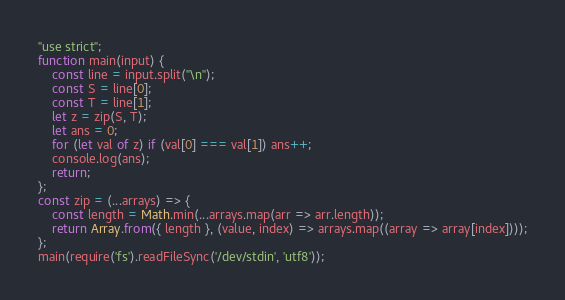Convert code to text. <code><loc_0><loc_0><loc_500><loc_500><_JavaScript_>"use strict";
function main(input) {
    const line = input.split("\n");
    const S = line[0];
    const T = line[1];
    let z = zip(S, T);
    let ans = 0;
    for (let val of z) if (val[0] === val[1]) ans++;
    console.log(ans);
    return;
};
const zip = (...arrays) => {
    const length = Math.min(...arrays.map(arr => arr.length));
    return Array.from({ length }, (value, index) => arrays.map((array => array[index])));
};
main(require('fs').readFileSync('/dev/stdin', 'utf8'));</code> 